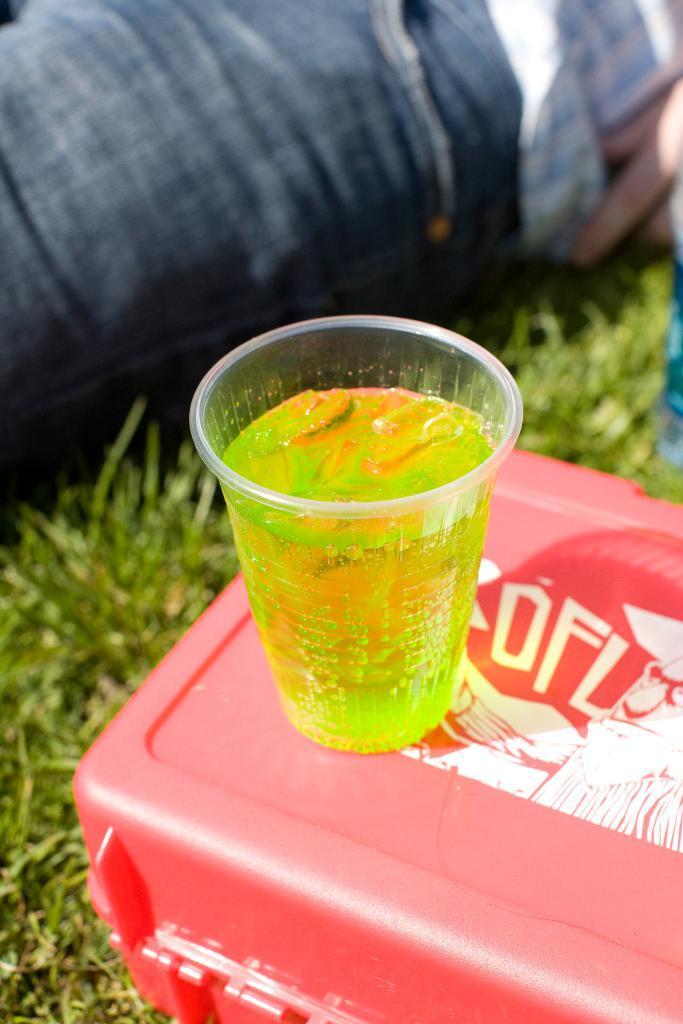Can you describe this image briefly? In the center of the image we can see a glass containing a drink placed on the box. At the bottom there is grass. In the background we can see a person's leg. 